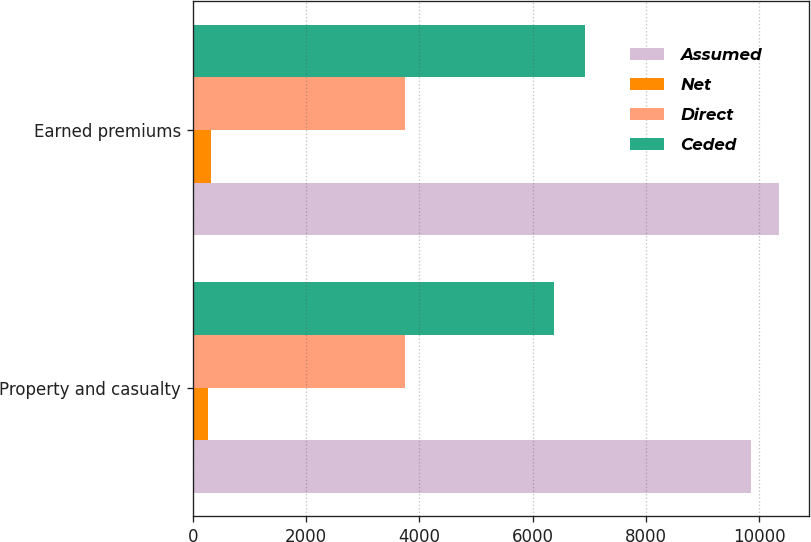Convert chart. <chart><loc_0><loc_0><loc_500><loc_500><stacked_bar_chart><ecel><fcel>Property and casualty<fcel>Earned premiums<nl><fcel>Assumed<fcel>9853<fcel>10351<nl><fcel>Net<fcel>274<fcel>324<nl><fcel>Direct<fcel>3754<fcel>3754<nl><fcel>Ceded<fcel>6373<fcel>6921<nl></chart> 